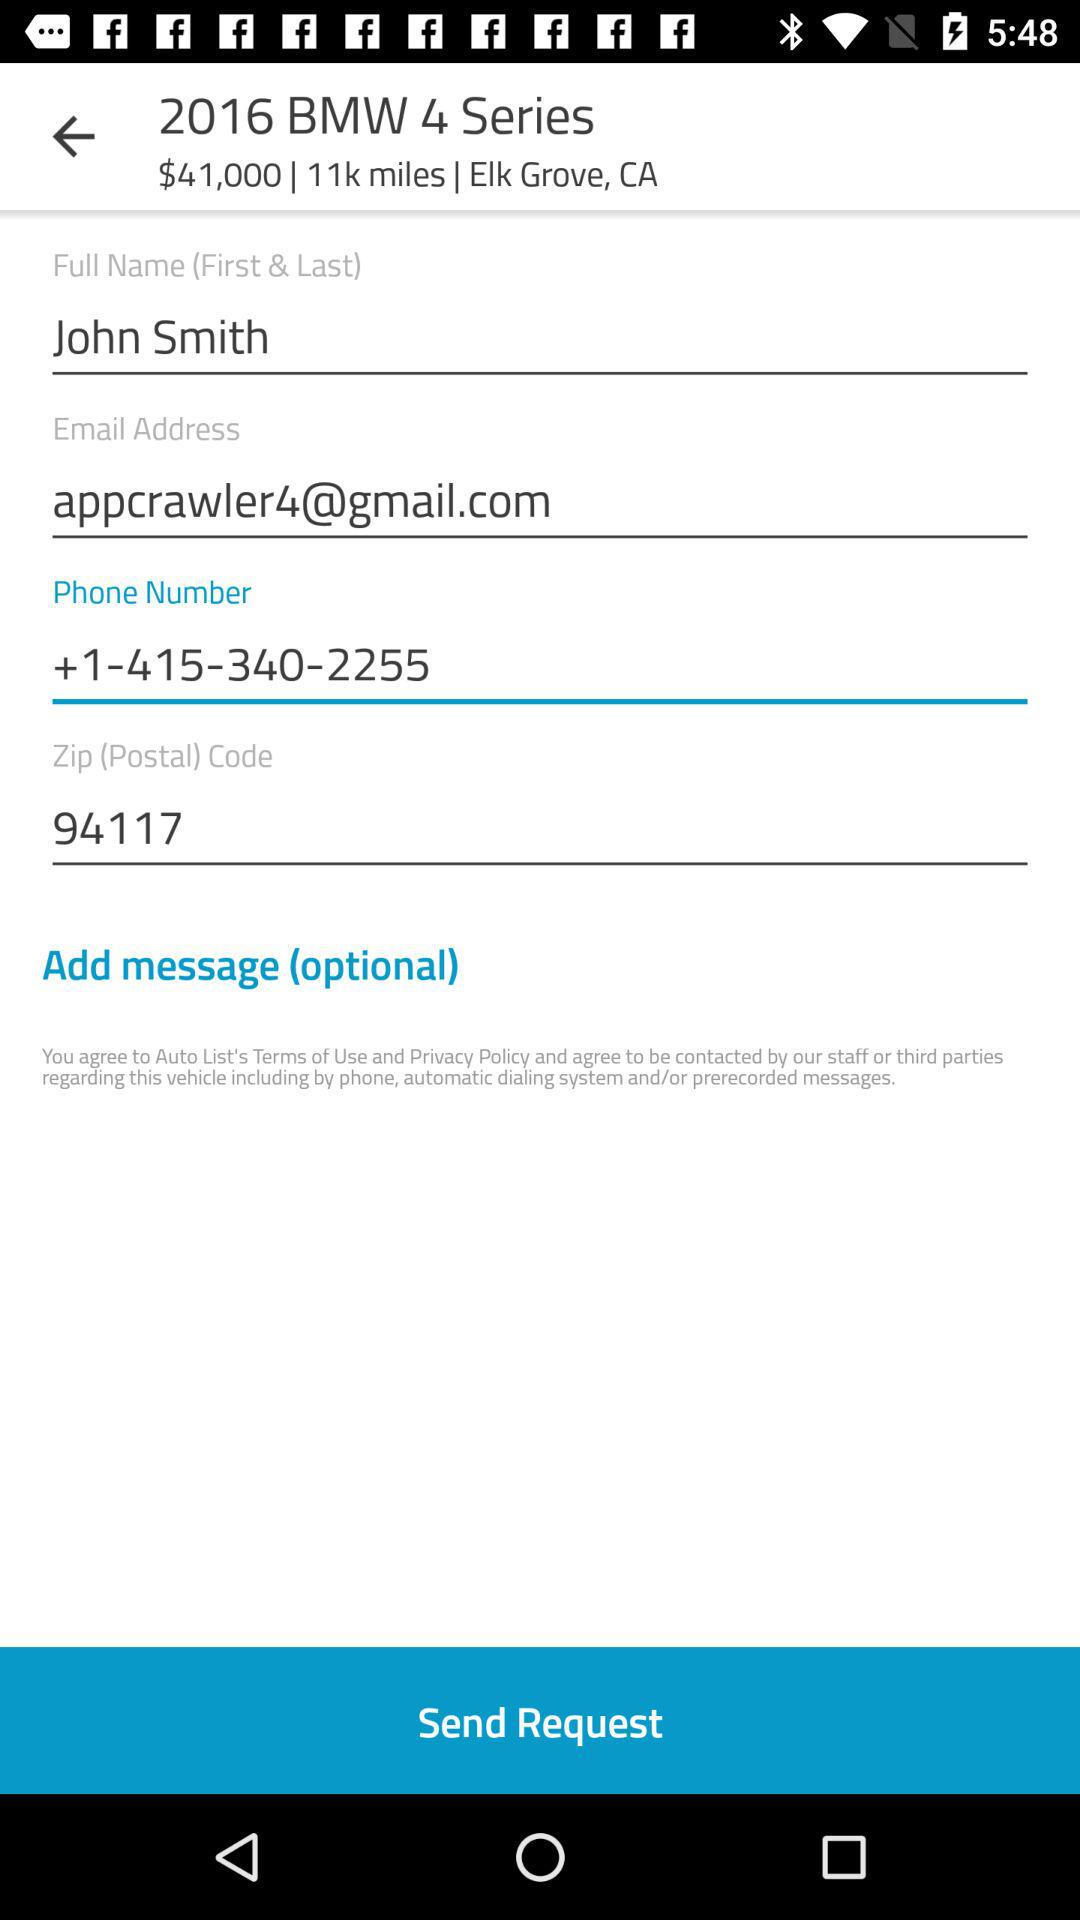What is the Zip code? The Zip code is 94117. 